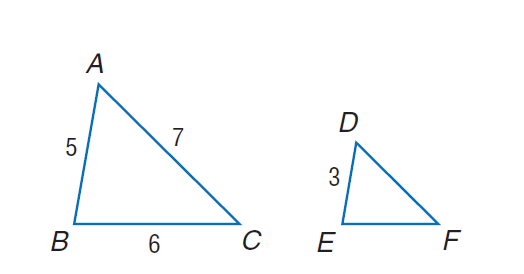Question: Find the perimeter of the given triangle \triangle D E F, if \triangle A B C \sim \triangle D E F, A B = 5, B C = 6, A C = 7, and D E = 3.
Choices:
A. 9.2
B. 10.8
C. 18
D. 31.7
Answer with the letter. Answer: B 